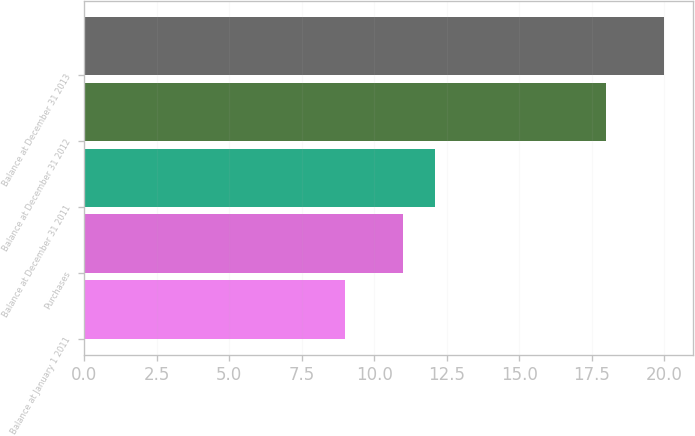<chart> <loc_0><loc_0><loc_500><loc_500><bar_chart><fcel>Balance at January 1 2011<fcel>Purchases<fcel>Balance at December 31 2011<fcel>Balance at December 31 2012<fcel>Balance at December 31 2013<nl><fcel>9<fcel>11<fcel>12.1<fcel>18<fcel>20<nl></chart> 